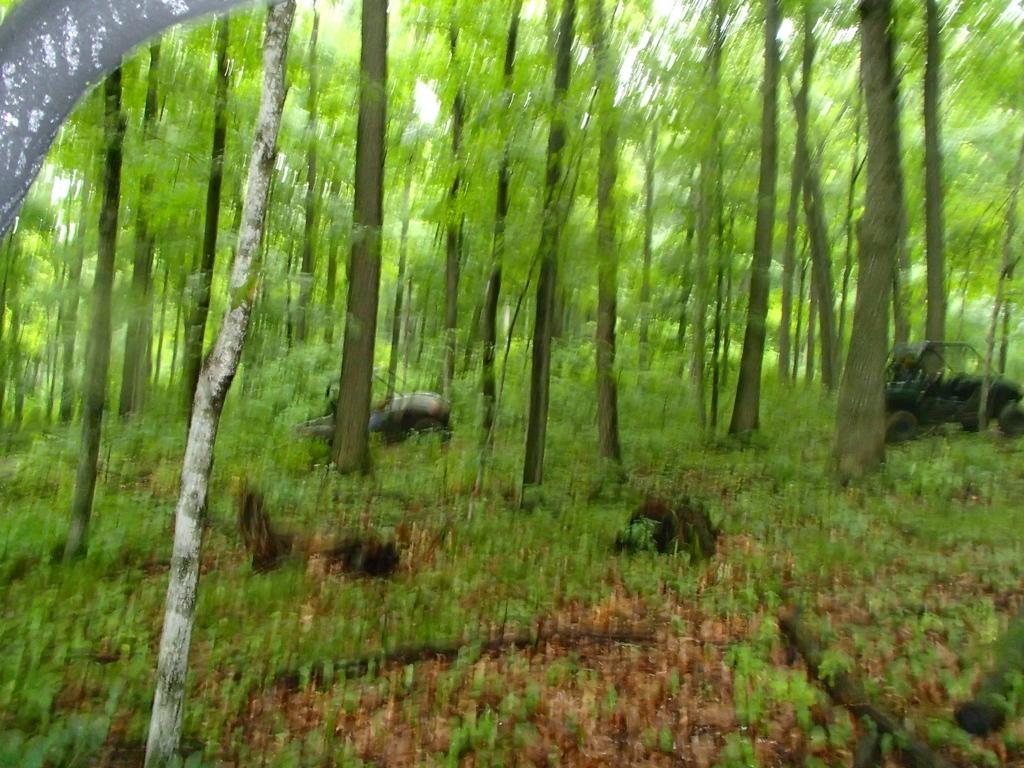Describe this image in one or two sentences. This picture is slightly blurred, where I can see planets on the ground and I can see trees. 